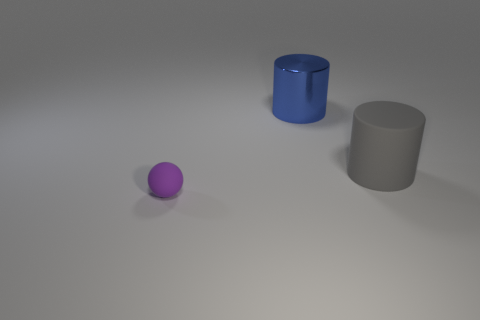There is a thing that is behind the big gray matte object; what is its size?
Your response must be concise. Large. There is a cylinder in front of the metal thing; is its size the same as the purple thing?
Ensure brevity in your answer.  No. Are there any other things of the same color as the tiny rubber thing?
Make the answer very short. No. What is the shape of the large rubber object?
Provide a short and direct response. Cylinder. How many objects are behind the tiny purple ball and left of the big gray rubber cylinder?
Offer a very short reply. 1. Does the large metal cylinder have the same color as the matte cylinder?
Your answer should be very brief. No. There is another large object that is the same shape as the big gray matte thing; what material is it?
Give a very brief answer. Metal. Is there anything else that is the same material as the large blue object?
Offer a terse response. No. Is the number of rubber objects on the left side of the metal object the same as the number of metal objects that are in front of the tiny object?
Your answer should be compact. No. Is the blue object made of the same material as the small purple object?
Make the answer very short. No. 